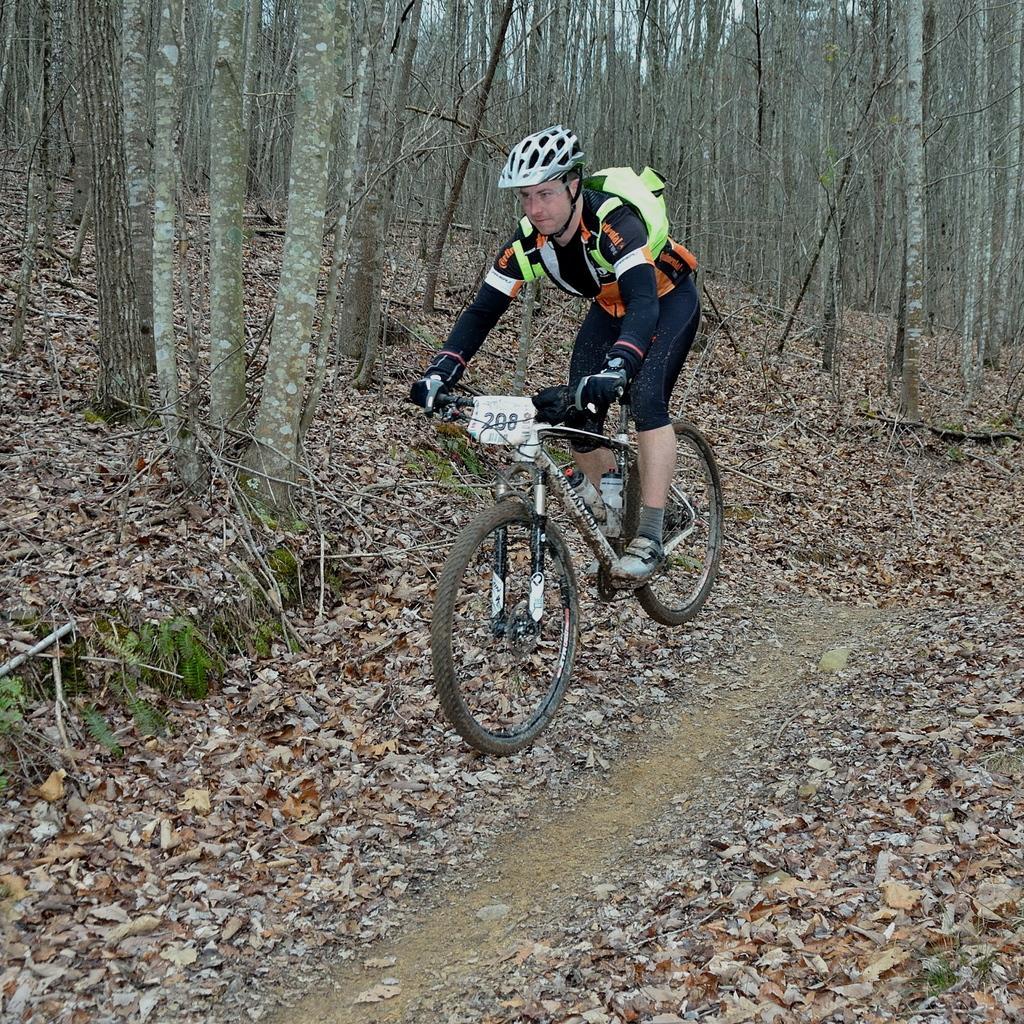In one or two sentences, can you explain what this image depicts? This picture shows a man riding a bicycle. He wore a backpack on is back and he wore a helmet on his head and we see a number to the bicycle and we see trees and dried leaves on the ground. 